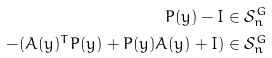Convert formula to latex. <formula><loc_0><loc_0><loc_500><loc_500>P ( y ) - I & \in \mathcal { S } ^ { G } _ { n } \\ - ( A ( y ) ^ { T } P ( y ) + P ( y ) A ( y ) + I ) & \in \mathcal { S } ^ { G } _ { n } \\</formula> 